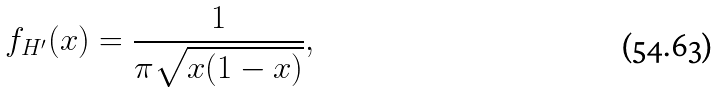<formula> <loc_0><loc_0><loc_500><loc_500>f _ { H ^ { \prime } } ( x ) = \frac { 1 } { \pi \sqrt { x ( 1 - x ) } } ,</formula> 